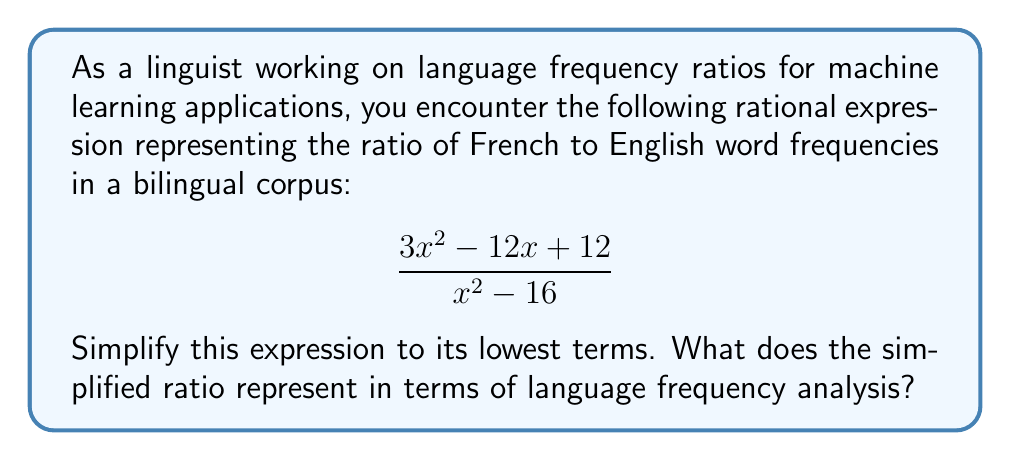Can you answer this question? Let's simplify this rational expression step-by-step:

1) First, we need to factor both the numerator and denominator:

   Numerator: $3x^2 - 12x + 12$
   This is a quadratic expression. We can factor it as:
   $3(x^2 - 4x + 4) = 3(x - 2)^2$

   Denominator: $x^2 - 16$
   This is a difference of squares. We can factor it as:
   $(x + 4)(x - 4)$

2) Now our expression looks like this:

   $$\frac{3(x - 2)^2}{(x + 4)(x - 4)}$$

3) We can see that $(x - 2)$ is a factor in the numerator, but it doesn't have any common factors with the denominator. Therefore, this is the simplest form of the rational expression.

4) In terms of language frequency analysis, this simplified ratio represents:

   - The numerator $3(x - 2)^2$ could represent the frequency of French words, with $x$ possibly being a variable related to text length or corpus size.
   - The denominator $(x + 4)(x - 4)$ could represent the frequency of English words in the same corpus.
   - The ratio between these two gives us a comparison of French to English word frequencies, which could be useful in analyzing bilingual texts or in developing machine learning models for language translation or bilingual text generation.
Answer: $$\frac{3(x - 2)^2}{(x + 4)(x - 4)}$$ 